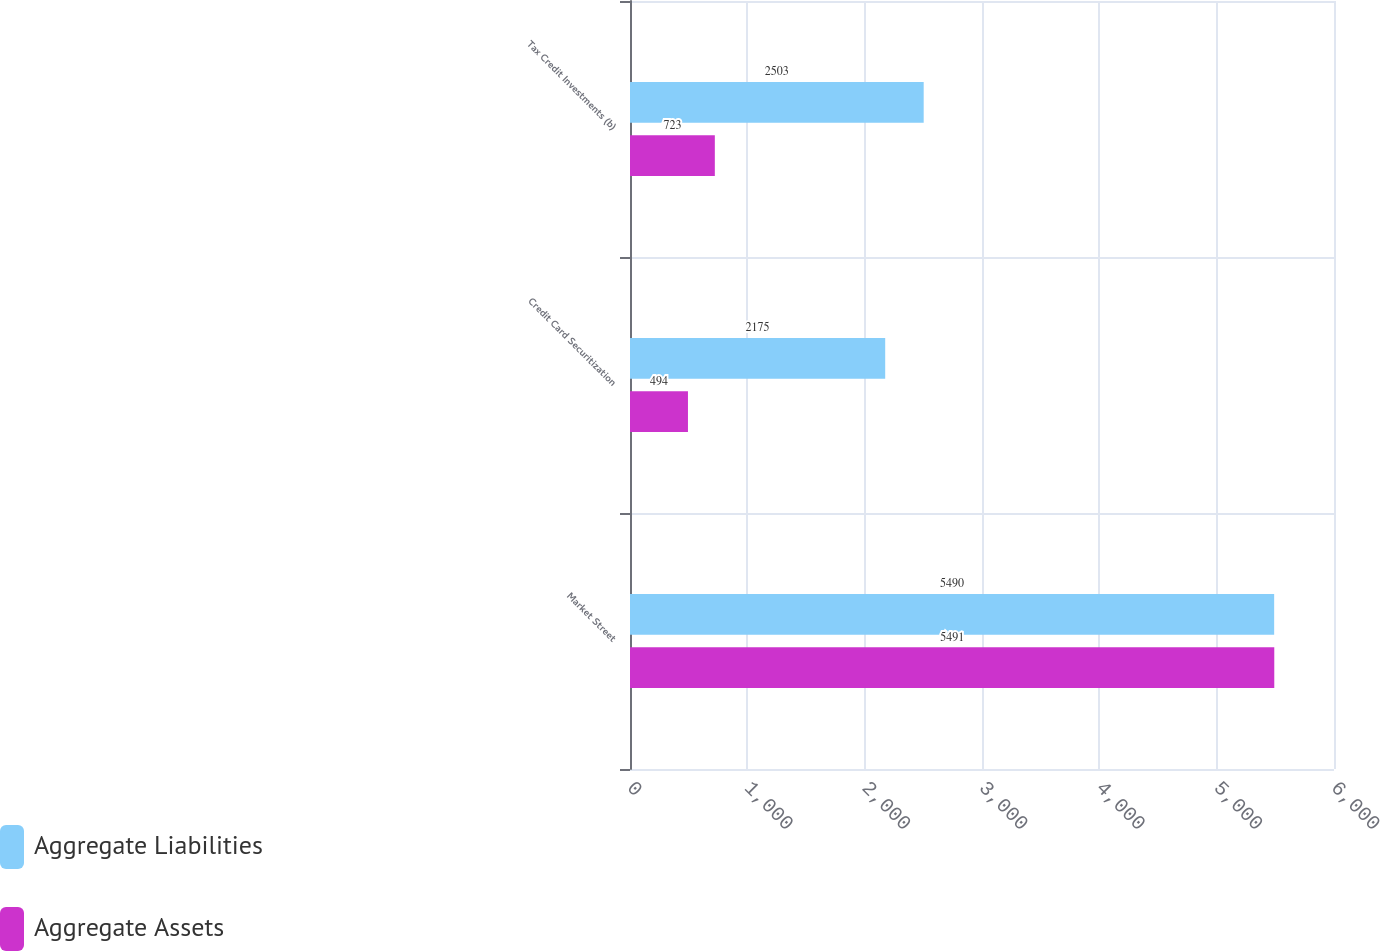<chart> <loc_0><loc_0><loc_500><loc_500><stacked_bar_chart><ecel><fcel>Market Street<fcel>Credit Card Securitization<fcel>Tax Credit Investments (b)<nl><fcel>Aggregate Liabilities<fcel>5490<fcel>2175<fcel>2503<nl><fcel>Aggregate Assets<fcel>5491<fcel>494<fcel>723<nl></chart> 